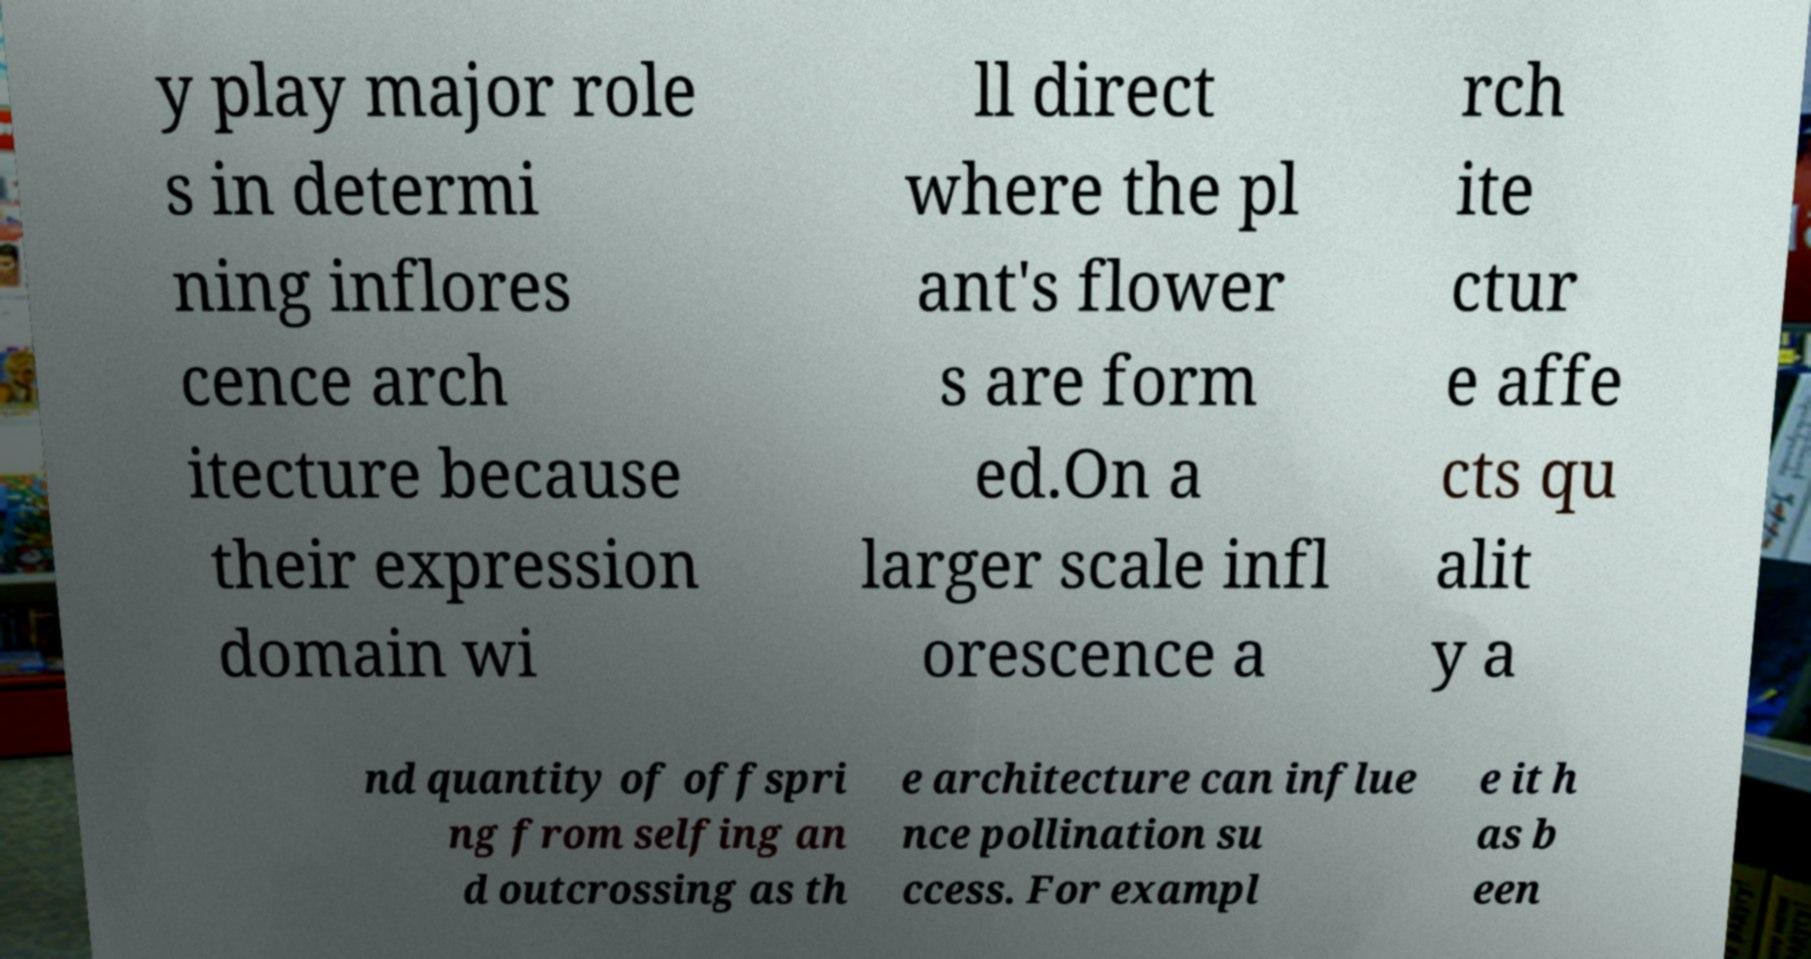What messages or text are displayed in this image? I need them in a readable, typed format. y play major role s in determi ning inflores cence arch itecture because their expression domain wi ll direct where the pl ant's flower s are form ed.On a larger scale infl orescence a rch ite ctur e affe cts qu alit y a nd quantity of offspri ng from selfing an d outcrossing as th e architecture can influe nce pollination su ccess. For exampl e it h as b een 